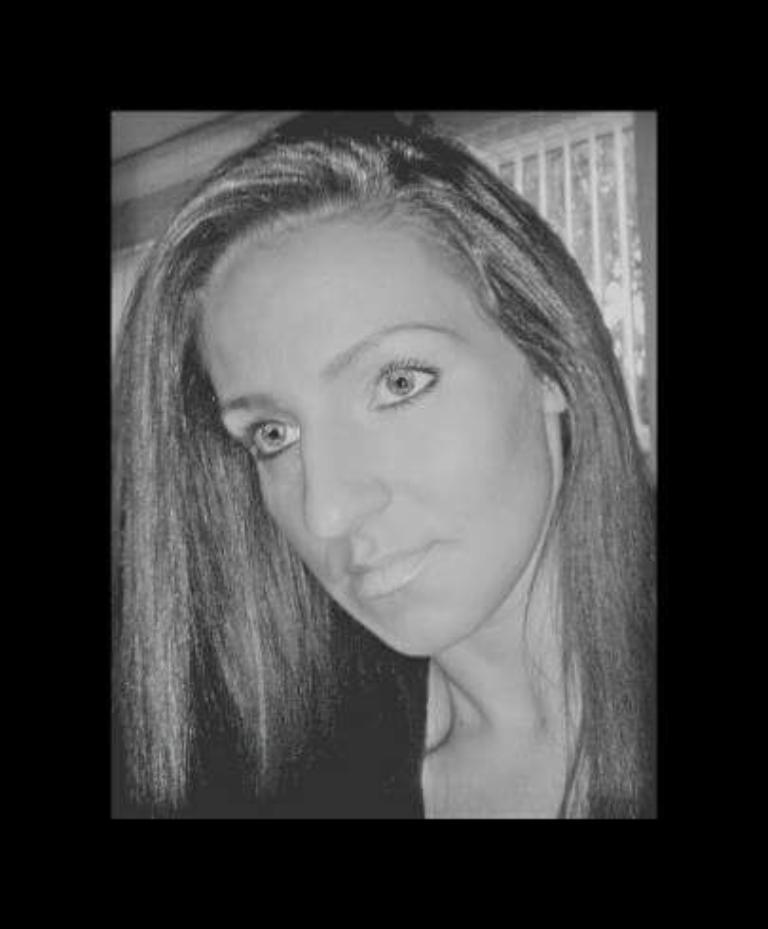Who is present in the image? There is a woman in the image. What can be seen in the background of the image? There is a grill in the background of the image. What type of string is the woman using to control the tiger in the image? There is no tiger present in the image, and therefore no string or control is needed. 